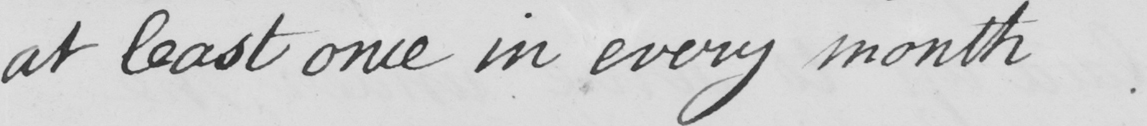Can you tell me what this handwritten text says? at least once in every month. 